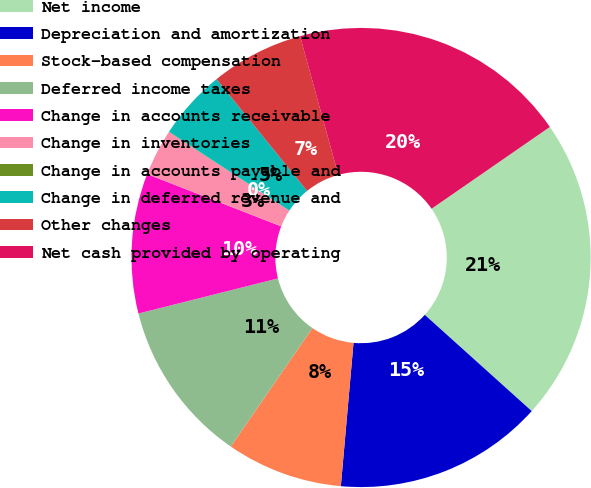Convert chart to OTSL. <chart><loc_0><loc_0><loc_500><loc_500><pie_chart><fcel>Net income<fcel>Depreciation and amortization<fcel>Stock-based compensation<fcel>Deferred income taxes<fcel>Change in accounts receivable<fcel>Change in inventories<fcel>Change in accounts payable and<fcel>Change in deferred revenue and<fcel>Other changes<fcel>Net cash provided by operating<nl><fcel>21.29%<fcel>14.74%<fcel>8.2%<fcel>11.47%<fcel>9.84%<fcel>3.29%<fcel>0.02%<fcel>4.93%<fcel>6.56%<fcel>19.65%<nl></chart> 